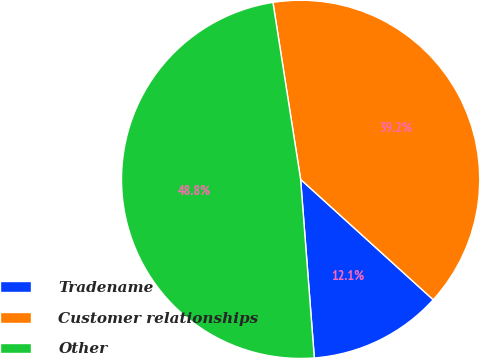Convert chart to OTSL. <chart><loc_0><loc_0><loc_500><loc_500><pie_chart><fcel>Tradename<fcel>Customer relationships<fcel>Other<nl><fcel>12.05%<fcel>39.2%<fcel>48.75%<nl></chart> 